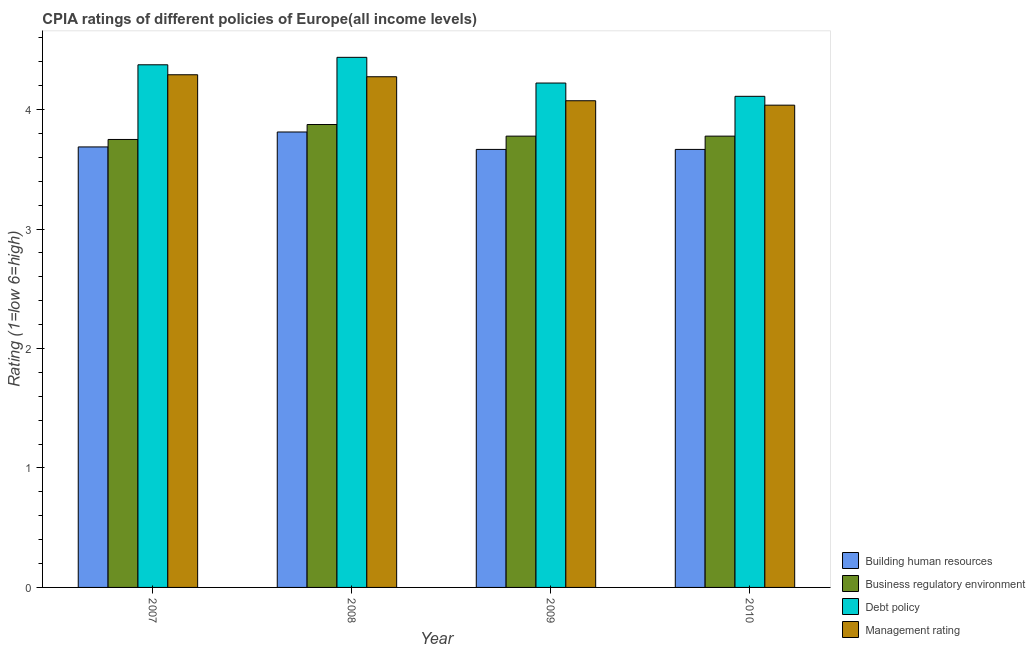Are the number of bars per tick equal to the number of legend labels?
Make the answer very short. Yes. How many bars are there on the 4th tick from the left?
Keep it short and to the point. 4. What is the label of the 4th group of bars from the left?
Keep it short and to the point. 2010. In how many cases, is the number of bars for a given year not equal to the number of legend labels?
Offer a terse response. 0. What is the cpia rating of management in 2009?
Your answer should be very brief. 4.07. Across all years, what is the maximum cpia rating of building human resources?
Keep it short and to the point. 3.81. Across all years, what is the minimum cpia rating of management?
Your response must be concise. 4.04. In which year was the cpia rating of debt policy maximum?
Keep it short and to the point. 2008. In which year was the cpia rating of business regulatory environment minimum?
Your answer should be very brief. 2007. What is the total cpia rating of building human resources in the graph?
Give a very brief answer. 14.83. What is the difference between the cpia rating of business regulatory environment in 2007 and that in 2009?
Keep it short and to the point. -0.03. What is the difference between the cpia rating of debt policy in 2008 and the cpia rating of building human resources in 2010?
Offer a very short reply. 0.33. What is the average cpia rating of debt policy per year?
Make the answer very short. 4.29. In the year 2009, what is the difference between the cpia rating of building human resources and cpia rating of debt policy?
Make the answer very short. 0. In how many years, is the cpia rating of debt policy greater than 0.8?
Your answer should be very brief. 4. What is the ratio of the cpia rating of business regulatory environment in 2009 to that in 2010?
Your answer should be very brief. 1. Is the cpia rating of management in 2007 less than that in 2009?
Offer a terse response. No. What is the difference between the highest and the second highest cpia rating of debt policy?
Provide a succinct answer. 0.06. What is the difference between the highest and the lowest cpia rating of business regulatory environment?
Ensure brevity in your answer.  0.12. Is it the case that in every year, the sum of the cpia rating of management and cpia rating of business regulatory environment is greater than the sum of cpia rating of debt policy and cpia rating of building human resources?
Give a very brief answer. No. What does the 3rd bar from the left in 2009 represents?
Keep it short and to the point. Debt policy. What does the 4th bar from the right in 2007 represents?
Offer a very short reply. Building human resources. Is it the case that in every year, the sum of the cpia rating of building human resources and cpia rating of business regulatory environment is greater than the cpia rating of debt policy?
Ensure brevity in your answer.  Yes. Does the graph contain any zero values?
Your answer should be compact. No. Where does the legend appear in the graph?
Your answer should be very brief. Bottom right. How are the legend labels stacked?
Make the answer very short. Vertical. What is the title of the graph?
Provide a short and direct response. CPIA ratings of different policies of Europe(all income levels). Does "PFC gas" appear as one of the legend labels in the graph?
Your answer should be compact. No. What is the label or title of the X-axis?
Make the answer very short. Year. What is the label or title of the Y-axis?
Provide a short and direct response. Rating (1=low 6=high). What is the Rating (1=low 6=high) in Building human resources in 2007?
Give a very brief answer. 3.69. What is the Rating (1=low 6=high) in Business regulatory environment in 2007?
Offer a very short reply. 3.75. What is the Rating (1=low 6=high) of Debt policy in 2007?
Offer a very short reply. 4.38. What is the Rating (1=low 6=high) of Management rating in 2007?
Your answer should be very brief. 4.29. What is the Rating (1=low 6=high) of Building human resources in 2008?
Your response must be concise. 3.81. What is the Rating (1=low 6=high) in Business regulatory environment in 2008?
Provide a short and direct response. 3.88. What is the Rating (1=low 6=high) in Debt policy in 2008?
Your response must be concise. 4.44. What is the Rating (1=low 6=high) in Management rating in 2008?
Offer a very short reply. 4.28. What is the Rating (1=low 6=high) of Building human resources in 2009?
Your answer should be compact. 3.67. What is the Rating (1=low 6=high) in Business regulatory environment in 2009?
Provide a short and direct response. 3.78. What is the Rating (1=low 6=high) of Debt policy in 2009?
Your answer should be compact. 4.22. What is the Rating (1=low 6=high) in Management rating in 2009?
Your response must be concise. 4.07. What is the Rating (1=low 6=high) of Building human resources in 2010?
Your response must be concise. 3.67. What is the Rating (1=low 6=high) in Business regulatory environment in 2010?
Offer a terse response. 3.78. What is the Rating (1=low 6=high) of Debt policy in 2010?
Offer a terse response. 4.11. What is the Rating (1=low 6=high) of Management rating in 2010?
Ensure brevity in your answer.  4.04. Across all years, what is the maximum Rating (1=low 6=high) in Building human resources?
Your response must be concise. 3.81. Across all years, what is the maximum Rating (1=low 6=high) of Business regulatory environment?
Ensure brevity in your answer.  3.88. Across all years, what is the maximum Rating (1=low 6=high) of Debt policy?
Keep it short and to the point. 4.44. Across all years, what is the maximum Rating (1=low 6=high) of Management rating?
Make the answer very short. 4.29. Across all years, what is the minimum Rating (1=low 6=high) in Building human resources?
Provide a succinct answer. 3.67. Across all years, what is the minimum Rating (1=low 6=high) in Business regulatory environment?
Offer a terse response. 3.75. Across all years, what is the minimum Rating (1=low 6=high) in Debt policy?
Ensure brevity in your answer.  4.11. Across all years, what is the minimum Rating (1=low 6=high) in Management rating?
Give a very brief answer. 4.04. What is the total Rating (1=low 6=high) in Building human resources in the graph?
Keep it short and to the point. 14.83. What is the total Rating (1=low 6=high) of Business regulatory environment in the graph?
Ensure brevity in your answer.  15.18. What is the total Rating (1=low 6=high) of Debt policy in the graph?
Keep it short and to the point. 17.15. What is the total Rating (1=low 6=high) of Management rating in the graph?
Keep it short and to the point. 16.68. What is the difference between the Rating (1=low 6=high) of Building human resources in 2007 and that in 2008?
Make the answer very short. -0.12. What is the difference between the Rating (1=low 6=high) of Business regulatory environment in 2007 and that in 2008?
Provide a succinct answer. -0.12. What is the difference between the Rating (1=low 6=high) of Debt policy in 2007 and that in 2008?
Your answer should be very brief. -0.06. What is the difference between the Rating (1=low 6=high) of Management rating in 2007 and that in 2008?
Give a very brief answer. 0.02. What is the difference between the Rating (1=low 6=high) in Building human resources in 2007 and that in 2009?
Offer a very short reply. 0.02. What is the difference between the Rating (1=low 6=high) in Business regulatory environment in 2007 and that in 2009?
Your answer should be compact. -0.03. What is the difference between the Rating (1=low 6=high) in Debt policy in 2007 and that in 2009?
Make the answer very short. 0.15. What is the difference between the Rating (1=low 6=high) in Management rating in 2007 and that in 2009?
Your answer should be very brief. 0.22. What is the difference between the Rating (1=low 6=high) of Building human resources in 2007 and that in 2010?
Provide a succinct answer. 0.02. What is the difference between the Rating (1=low 6=high) in Business regulatory environment in 2007 and that in 2010?
Offer a terse response. -0.03. What is the difference between the Rating (1=low 6=high) in Debt policy in 2007 and that in 2010?
Your answer should be compact. 0.26. What is the difference between the Rating (1=low 6=high) in Management rating in 2007 and that in 2010?
Your response must be concise. 0.25. What is the difference between the Rating (1=low 6=high) in Building human resources in 2008 and that in 2009?
Provide a short and direct response. 0.15. What is the difference between the Rating (1=low 6=high) of Business regulatory environment in 2008 and that in 2009?
Provide a succinct answer. 0.1. What is the difference between the Rating (1=low 6=high) of Debt policy in 2008 and that in 2009?
Provide a succinct answer. 0.22. What is the difference between the Rating (1=low 6=high) in Management rating in 2008 and that in 2009?
Your response must be concise. 0.2. What is the difference between the Rating (1=low 6=high) of Building human resources in 2008 and that in 2010?
Provide a succinct answer. 0.15. What is the difference between the Rating (1=low 6=high) in Business regulatory environment in 2008 and that in 2010?
Ensure brevity in your answer.  0.1. What is the difference between the Rating (1=low 6=high) in Debt policy in 2008 and that in 2010?
Make the answer very short. 0.33. What is the difference between the Rating (1=low 6=high) in Management rating in 2008 and that in 2010?
Make the answer very short. 0.24. What is the difference between the Rating (1=low 6=high) of Business regulatory environment in 2009 and that in 2010?
Ensure brevity in your answer.  0. What is the difference between the Rating (1=low 6=high) of Debt policy in 2009 and that in 2010?
Your answer should be very brief. 0.11. What is the difference between the Rating (1=low 6=high) in Management rating in 2009 and that in 2010?
Offer a very short reply. 0.04. What is the difference between the Rating (1=low 6=high) of Building human resources in 2007 and the Rating (1=low 6=high) of Business regulatory environment in 2008?
Your answer should be compact. -0.19. What is the difference between the Rating (1=low 6=high) of Building human resources in 2007 and the Rating (1=low 6=high) of Debt policy in 2008?
Your response must be concise. -0.75. What is the difference between the Rating (1=low 6=high) of Building human resources in 2007 and the Rating (1=low 6=high) of Management rating in 2008?
Give a very brief answer. -0.59. What is the difference between the Rating (1=low 6=high) in Business regulatory environment in 2007 and the Rating (1=low 6=high) in Debt policy in 2008?
Give a very brief answer. -0.69. What is the difference between the Rating (1=low 6=high) in Business regulatory environment in 2007 and the Rating (1=low 6=high) in Management rating in 2008?
Your answer should be compact. -0.53. What is the difference between the Rating (1=low 6=high) in Building human resources in 2007 and the Rating (1=low 6=high) in Business regulatory environment in 2009?
Keep it short and to the point. -0.09. What is the difference between the Rating (1=low 6=high) in Building human resources in 2007 and the Rating (1=low 6=high) in Debt policy in 2009?
Offer a very short reply. -0.53. What is the difference between the Rating (1=low 6=high) in Building human resources in 2007 and the Rating (1=low 6=high) in Management rating in 2009?
Your response must be concise. -0.39. What is the difference between the Rating (1=low 6=high) in Business regulatory environment in 2007 and the Rating (1=low 6=high) in Debt policy in 2009?
Your response must be concise. -0.47. What is the difference between the Rating (1=low 6=high) in Business regulatory environment in 2007 and the Rating (1=low 6=high) in Management rating in 2009?
Give a very brief answer. -0.32. What is the difference between the Rating (1=low 6=high) of Debt policy in 2007 and the Rating (1=low 6=high) of Management rating in 2009?
Your answer should be very brief. 0.3. What is the difference between the Rating (1=low 6=high) of Building human resources in 2007 and the Rating (1=low 6=high) of Business regulatory environment in 2010?
Keep it short and to the point. -0.09. What is the difference between the Rating (1=low 6=high) in Building human resources in 2007 and the Rating (1=low 6=high) in Debt policy in 2010?
Provide a short and direct response. -0.42. What is the difference between the Rating (1=low 6=high) of Building human resources in 2007 and the Rating (1=low 6=high) of Management rating in 2010?
Keep it short and to the point. -0.35. What is the difference between the Rating (1=low 6=high) in Business regulatory environment in 2007 and the Rating (1=low 6=high) in Debt policy in 2010?
Ensure brevity in your answer.  -0.36. What is the difference between the Rating (1=low 6=high) in Business regulatory environment in 2007 and the Rating (1=low 6=high) in Management rating in 2010?
Ensure brevity in your answer.  -0.29. What is the difference between the Rating (1=low 6=high) in Debt policy in 2007 and the Rating (1=low 6=high) in Management rating in 2010?
Your answer should be very brief. 0.34. What is the difference between the Rating (1=low 6=high) in Building human resources in 2008 and the Rating (1=low 6=high) in Business regulatory environment in 2009?
Your answer should be very brief. 0.03. What is the difference between the Rating (1=low 6=high) in Building human resources in 2008 and the Rating (1=low 6=high) in Debt policy in 2009?
Ensure brevity in your answer.  -0.41. What is the difference between the Rating (1=low 6=high) of Building human resources in 2008 and the Rating (1=low 6=high) of Management rating in 2009?
Provide a succinct answer. -0.26. What is the difference between the Rating (1=low 6=high) of Business regulatory environment in 2008 and the Rating (1=low 6=high) of Debt policy in 2009?
Provide a short and direct response. -0.35. What is the difference between the Rating (1=low 6=high) of Business regulatory environment in 2008 and the Rating (1=low 6=high) of Management rating in 2009?
Provide a short and direct response. -0.2. What is the difference between the Rating (1=low 6=high) of Debt policy in 2008 and the Rating (1=low 6=high) of Management rating in 2009?
Your response must be concise. 0.36. What is the difference between the Rating (1=low 6=high) of Building human resources in 2008 and the Rating (1=low 6=high) of Business regulatory environment in 2010?
Ensure brevity in your answer.  0.03. What is the difference between the Rating (1=low 6=high) of Building human resources in 2008 and the Rating (1=low 6=high) of Debt policy in 2010?
Ensure brevity in your answer.  -0.3. What is the difference between the Rating (1=low 6=high) of Building human resources in 2008 and the Rating (1=low 6=high) of Management rating in 2010?
Keep it short and to the point. -0.22. What is the difference between the Rating (1=low 6=high) in Business regulatory environment in 2008 and the Rating (1=low 6=high) in Debt policy in 2010?
Provide a succinct answer. -0.24. What is the difference between the Rating (1=low 6=high) of Business regulatory environment in 2008 and the Rating (1=low 6=high) of Management rating in 2010?
Give a very brief answer. -0.16. What is the difference between the Rating (1=low 6=high) in Debt policy in 2008 and the Rating (1=low 6=high) in Management rating in 2010?
Offer a very short reply. 0.4. What is the difference between the Rating (1=low 6=high) of Building human resources in 2009 and the Rating (1=low 6=high) of Business regulatory environment in 2010?
Make the answer very short. -0.11. What is the difference between the Rating (1=low 6=high) in Building human resources in 2009 and the Rating (1=low 6=high) in Debt policy in 2010?
Offer a very short reply. -0.44. What is the difference between the Rating (1=low 6=high) of Building human resources in 2009 and the Rating (1=low 6=high) of Management rating in 2010?
Keep it short and to the point. -0.37. What is the difference between the Rating (1=low 6=high) in Business regulatory environment in 2009 and the Rating (1=low 6=high) in Debt policy in 2010?
Keep it short and to the point. -0.33. What is the difference between the Rating (1=low 6=high) of Business regulatory environment in 2009 and the Rating (1=low 6=high) of Management rating in 2010?
Give a very brief answer. -0.26. What is the difference between the Rating (1=low 6=high) of Debt policy in 2009 and the Rating (1=low 6=high) of Management rating in 2010?
Your answer should be very brief. 0.19. What is the average Rating (1=low 6=high) in Building human resources per year?
Offer a very short reply. 3.71. What is the average Rating (1=low 6=high) of Business regulatory environment per year?
Your answer should be compact. 3.8. What is the average Rating (1=low 6=high) of Debt policy per year?
Offer a terse response. 4.29. What is the average Rating (1=low 6=high) in Management rating per year?
Provide a succinct answer. 4.17. In the year 2007, what is the difference between the Rating (1=low 6=high) of Building human resources and Rating (1=low 6=high) of Business regulatory environment?
Your answer should be compact. -0.06. In the year 2007, what is the difference between the Rating (1=low 6=high) of Building human resources and Rating (1=low 6=high) of Debt policy?
Your response must be concise. -0.69. In the year 2007, what is the difference between the Rating (1=low 6=high) in Building human resources and Rating (1=low 6=high) in Management rating?
Keep it short and to the point. -0.6. In the year 2007, what is the difference between the Rating (1=low 6=high) in Business regulatory environment and Rating (1=low 6=high) in Debt policy?
Provide a succinct answer. -0.62. In the year 2007, what is the difference between the Rating (1=low 6=high) of Business regulatory environment and Rating (1=low 6=high) of Management rating?
Your response must be concise. -0.54. In the year 2007, what is the difference between the Rating (1=low 6=high) of Debt policy and Rating (1=low 6=high) of Management rating?
Offer a terse response. 0.08. In the year 2008, what is the difference between the Rating (1=low 6=high) in Building human resources and Rating (1=low 6=high) in Business regulatory environment?
Give a very brief answer. -0.06. In the year 2008, what is the difference between the Rating (1=low 6=high) in Building human resources and Rating (1=low 6=high) in Debt policy?
Offer a very short reply. -0.62. In the year 2008, what is the difference between the Rating (1=low 6=high) in Building human resources and Rating (1=low 6=high) in Management rating?
Ensure brevity in your answer.  -0.46. In the year 2008, what is the difference between the Rating (1=low 6=high) in Business regulatory environment and Rating (1=low 6=high) in Debt policy?
Make the answer very short. -0.56. In the year 2008, what is the difference between the Rating (1=low 6=high) of Debt policy and Rating (1=low 6=high) of Management rating?
Give a very brief answer. 0.16. In the year 2009, what is the difference between the Rating (1=low 6=high) in Building human resources and Rating (1=low 6=high) in Business regulatory environment?
Keep it short and to the point. -0.11. In the year 2009, what is the difference between the Rating (1=low 6=high) in Building human resources and Rating (1=low 6=high) in Debt policy?
Make the answer very short. -0.56. In the year 2009, what is the difference between the Rating (1=low 6=high) in Building human resources and Rating (1=low 6=high) in Management rating?
Provide a short and direct response. -0.41. In the year 2009, what is the difference between the Rating (1=low 6=high) in Business regulatory environment and Rating (1=low 6=high) in Debt policy?
Provide a short and direct response. -0.44. In the year 2009, what is the difference between the Rating (1=low 6=high) in Business regulatory environment and Rating (1=low 6=high) in Management rating?
Your answer should be very brief. -0.3. In the year 2009, what is the difference between the Rating (1=low 6=high) of Debt policy and Rating (1=low 6=high) of Management rating?
Ensure brevity in your answer.  0.15. In the year 2010, what is the difference between the Rating (1=low 6=high) in Building human resources and Rating (1=low 6=high) in Business regulatory environment?
Your answer should be compact. -0.11. In the year 2010, what is the difference between the Rating (1=low 6=high) in Building human resources and Rating (1=low 6=high) in Debt policy?
Offer a terse response. -0.44. In the year 2010, what is the difference between the Rating (1=low 6=high) in Building human resources and Rating (1=low 6=high) in Management rating?
Provide a short and direct response. -0.37. In the year 2010, what is the difference between the Rating (1=low 6=high) in Business regulatory environment and Rating (1=low 6=high) in Management rating?
Provide a short and direct response. -0.26. In the year 2010, what is the difference between the Rating (1=low 6=high) of Debt policy and Rating (1=low 6=high) of Management rating?
Provide a succinct answer. 0.07. What is the ratio of the Rating (1=low 6=high) of Building human resources in 2007 to that in 2008?
Provide a succinct answer. 0.97. What is the ratio of the Rating (1=low 6=high) of Business regulatory environment in 2007 to that in 2008?
Give a very brief answer. 0.97. What is the ratio of the Rating (1=low 6=high) of Debt policy in 2007 to that in 2008?
Your answer should be compact. 0.99. What is the ratio of the Rating (1=low 6=high) in Business regulatory environment in 2007 to that in 2009?
Make the answer very short. 0.99. What is the ratio of the Rating (1=low 6=high) of Debt policy in 2007 to that in 2009?
Provide a short and direct response. 1.04. What is the ratio of the Rating (1=low 6=high) of Management rating in 2007 to that in 2009?
Make the answer very short. 1.05. What is the ratio of the Rating (1=low 6=high) of Debt policy in 2007 to that in 2010?
Offer a very short reply. 1.06. What is the ratio of the Rating (1=low 6=high) of Management rating in 2007 to that in 2010?
Keep it short and to the point. 1.06. What is the ratio of the Rating (1=low 6=high) in Building human resources in 2008 to that in 2009?
Keep it short and to the point. 1.04. What is the ratio of the Rating (1=low 6=high) of Business regulatory environment in 2008 to that in 2009?
Your answer should be very brief. 1.03. What is the ratio of the Rating (1=low 6=high) of Debt policy in 2008 to that in 2009?
Make the answer very short. 1.05. What is the ratio of the Rating (1=low 6=high) of Management rating in 2008 to that in 2009?
Offer a terse response. 1.05. What is the ratio of the Rating (1=low 6=high) in Building human resources in 2008 to that in 2010?
Offer a very short reply. 1.04. What is the ratio of the Rating (1=low 6=high) in Business regulatory environment in 2008 to that in 2010?
Your answer should be compact. 1.03. What is the ratio of the Rating (1=low 6=high) of Debt policy in 2008 to that in 2010?
Your answer should be very brief. 1.08. What is the ratio of the Rating (1=low 6=high) in Management rating in 2008 to that in 2010?
Your response must be concise. 1.06. What is the ratio of the Rating (1=low 6=high) in Business regulatory environment in 2009 to that in 2010?
Offer a very short reply. 1. What is the ratio of the Rating (1=low 6=high) in Debt policy in 2009 to that in 2010?
Give a very brief answer. 1.03. What is the ratio of the Rating (1=low 6=high) of Management rating in 2009 to that in 2010?
Your answer should be very brief. 1.01. What is the difference between the highest and the second highest Rating (1=low 6=high) in Business regulatory environment?
Offer a terse response. 0.1. What is the difference between the highest and the second highest Rating (1=low 6=high) of Debt policy?
Keep it short and to the point. 0.06. What is the difference between the highest and the second highest Rating (1=low 6=high) in Management rating?
Ensure brevity in your answer.  0.02. What is the difference between the highest and the lowest Rating (1=low 6=high) in Building human resources?
Make the answer very short. 0.15. What is the difference between the highest and the lowest Rating (1=low 6=high) in Debt policy?
Provide a short and direct response. 0.33. What is the difference between the highest and the lowest Rating (1=low 6=high) of Management rating?
Make the answer very short. 0.25. 